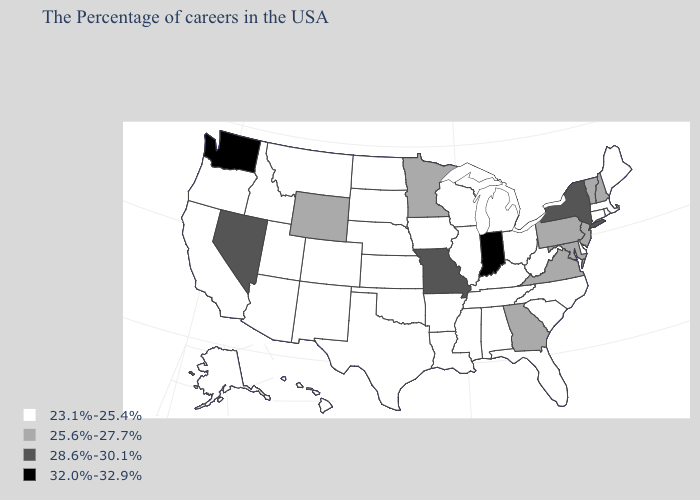Name the states that have a value in the range 25.6%-27.7%?
Be succinct. New Hampshire, Vermont, New Jersey, Maryland, Pennsylvania, Virginia, Georgia, Minnesota, Wyoming. What is the lowest value in the USA?
Short answer required. 23.1%-25.4%. Does Michigan have a higher value than North Carolina?
Be succinct. No. Does New Jersey have the same value as New Hampshire?
Keep it brief. Yes. Among the states that border Iowa , does Missouri have the highest value?
Be succinct. Yes. Among the states that border New York , does Vermont have the highest value?
Quick response, please. Yes. Among the states that border Connecticut , which have the lowest value?
Short answer required. Massachusetts, Rhode Island. What is the lowest value in the MidWest?
Write a very short answer. 23.1%-25.4%. Name the states that have a value in the range 28.6%-30.1%?
Quick response, please. New York, Missouri, Nevada. Which states have the lowest value in the USA?
Quick response, please. Maine, Massachusetts, Rhode Island, Connecticut, Delaware, North Carolina, South Carolina, West Virginia, Ohio, Florida, Michigan, Kentucky, Alabama, Tennessee, Wisconsin, Illinois, Mississippi, Louisiana, Arkansas, Iowa, Kansas, Nebraska, Oklahoma, Texas, South Dakota, North Dakota, Colorado, New Mexico, Utah, Montana, Arizona, Idaho, California, Oregon, Alaska, Hawaii. Name the states that have a value in the range 23.1%-25.4%?
Give a very brief answer. Maine, Massachusetts, Rhode Island, Connecticut, Delaware, North Carolina, South Carolina, West Virginia, Ohio, Florida, Michigan, Kentucky, Alabama, Tennessee, Wisconsin, Illinois, Mississippi, Louisiana, Arkansas, Iowa, Kansas, Nebraska, Oklahoma, Texas, South Dakota, North Dakota, Colorado, New Mexico, Utah, Montana, Arizona, Idaho, California, Oregon, Alaska, Hawaii. Which states have the lowest value in the Northeast?
Write a very short answer. Maine, Massachusetts, Rhode Island, Connecticut. What is the highest value in the MidWest ?
Quick response, please. 32.0%-32.9%. Which states have the highest value in the USA?
Keep it brief. Indiana, Washington. Which states have the lowest value in the USA?
Concise answer only. Maine, Massachusetts, Rhode Island, Connecticut, Delaware, North Carolina, South Carolina, West Virginia, Ohio, Florida, Michigan, Kentucky, Alabama, Tennessee, Wisconsin, Illinois, Mississippi, Louisiana, Arkansas, Iowa, Kansas, Nebraska, Oklahoma, Texas, South Dakota, North Dakota, Colorado, New Mexico, Utah, Montana, Arizona, Idaho, California, Oregon, Alaska, Hawaii. 